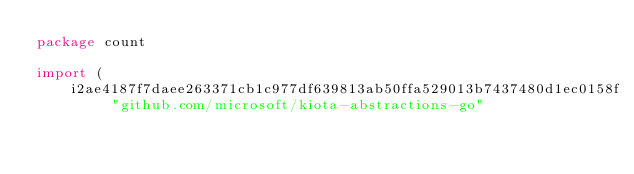Convert code to text. <code><loc_0><loc_0><loc_500><loc_500><_Go_>package count

import (
    i2ae4187f7daee263371cb1c977df639813ab50ffa529013b7437480d1ec0158f "github.com/microsoft/kiota-abstractions-go"</code> 